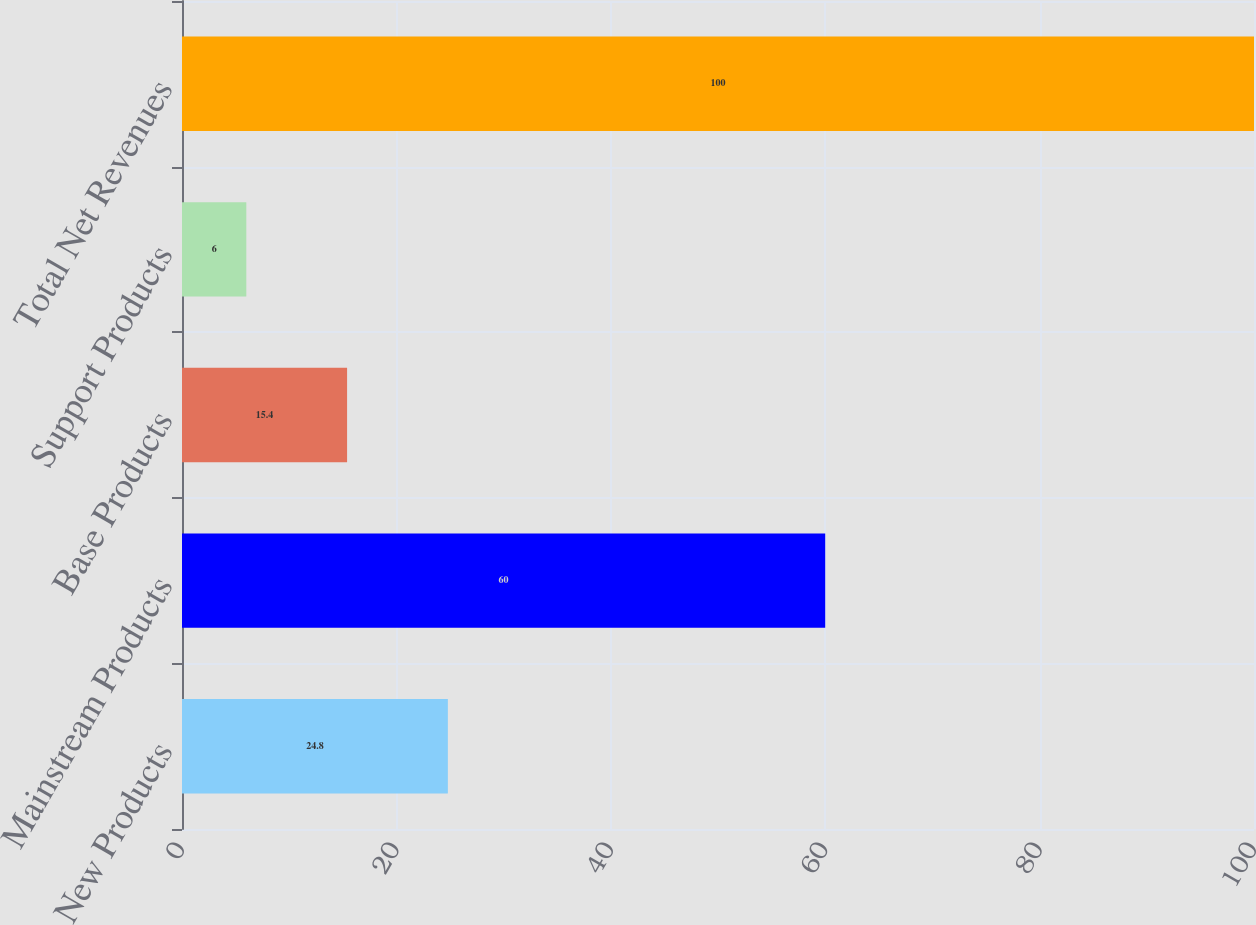Convert chart. <chart><loc_0><loc_0><loc_500><loc_500><bar_chart><fcel>New Products<fcel>Mainstream Products<fcel>Base Products<fcel>Support Products<fcel>Total Net Revenues<nl><fcel>24.8<fcel>60<fcel>15.4<fcel>6<fcel>100<nl></chart> 